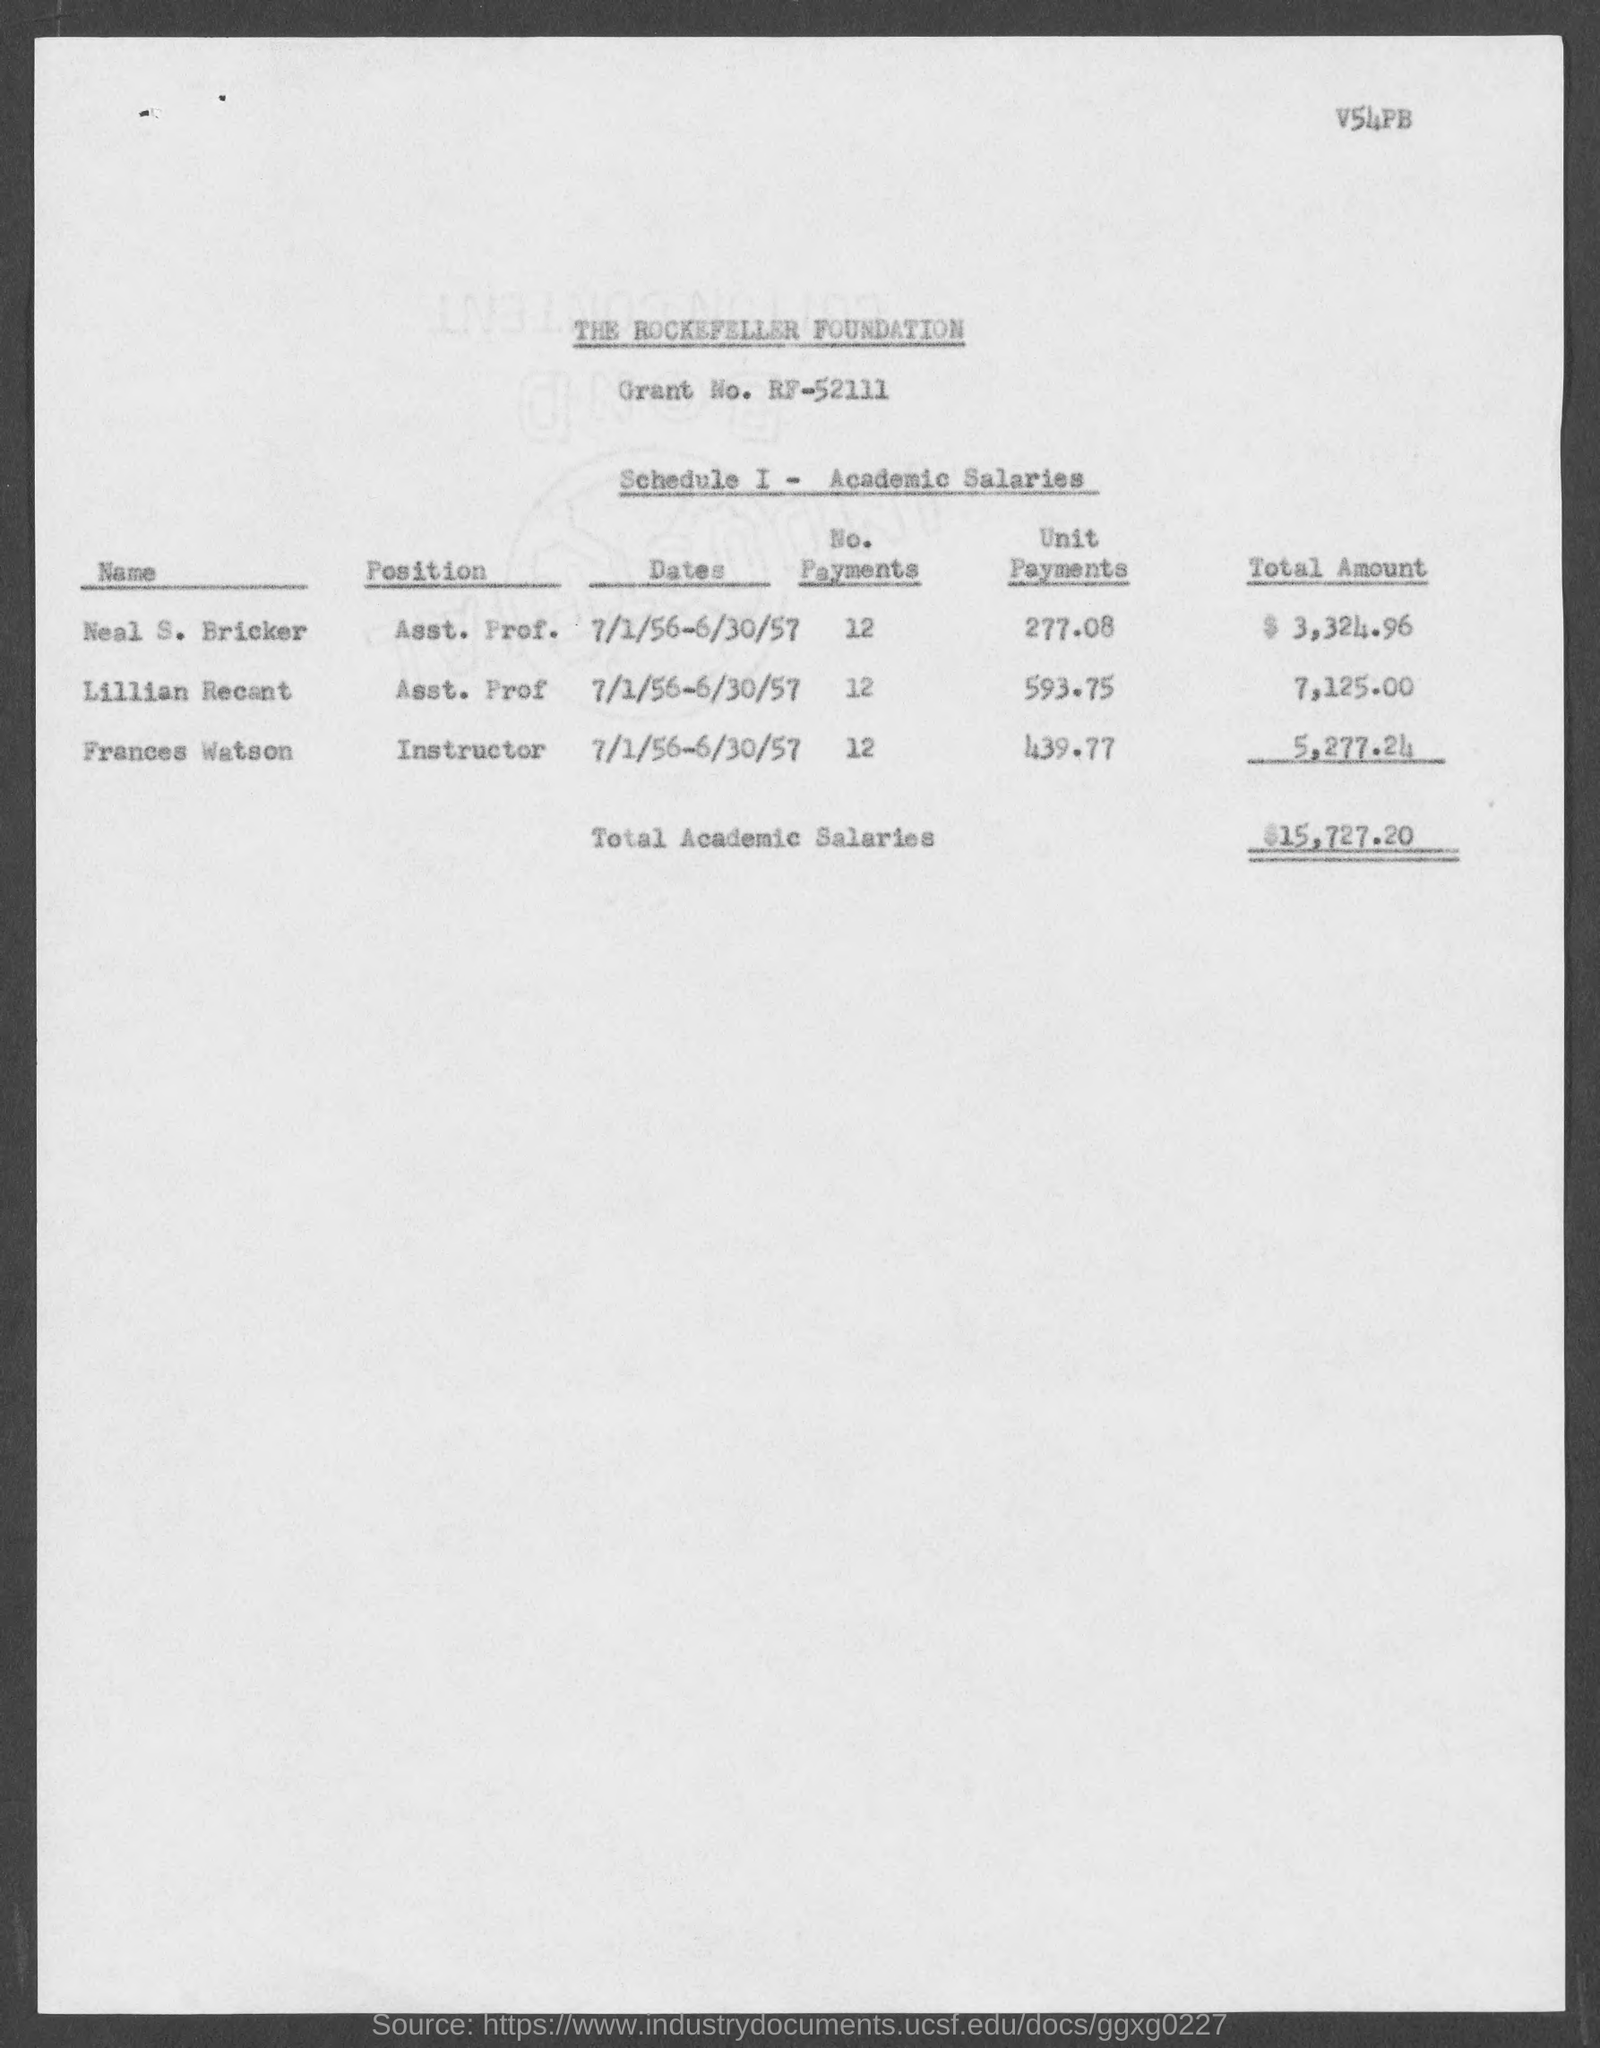What is the position of neal s. bricker ?
Provide a short and direct response. Asst. Prof. What is the position of lillian recant ?
Offer a very short reply. Asst. prof. What is the position of frances watson ?
Provide a short and direct response. Instructor. What is the total academic salaries ?
Make the answer very short. $15,727.20. What is the no. of payments for neal s. bricker ?
Your answer should be very brief. 12. What is the no. of payments for lillian recent ?
Offer a terse response. 12. What is the no. of payments for frances watson ?
Ensure brevity in your answer.  12. What is the unit payments for neal s. bricker ?
Provide a succinct answer. 277.08. What is the unit payments for lillian recent?
Offer a terse response. 593.75. What is the unit payments for frances watson ?
Offer a terse response. 439.77. 